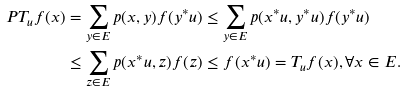<formula> <loc_0><loc_0><loc_500><loc_500>P T _ { u } f ( x ) & = \sum _ { y \in E } p ( x , y ) f ( y ^ { * } u ) \leq \sum _ { y \in E } p ( x ^ { * } u , y ^ { * } u ) f ( y ^ { * } u ) \\ & \leq \sum _ { z \in E } p ( x ^ { * } u , z ) f ( z ) \leq f ( x ^ { * } u ) = T _ { u } f ( x ) , \forall x \in E .</formula> 